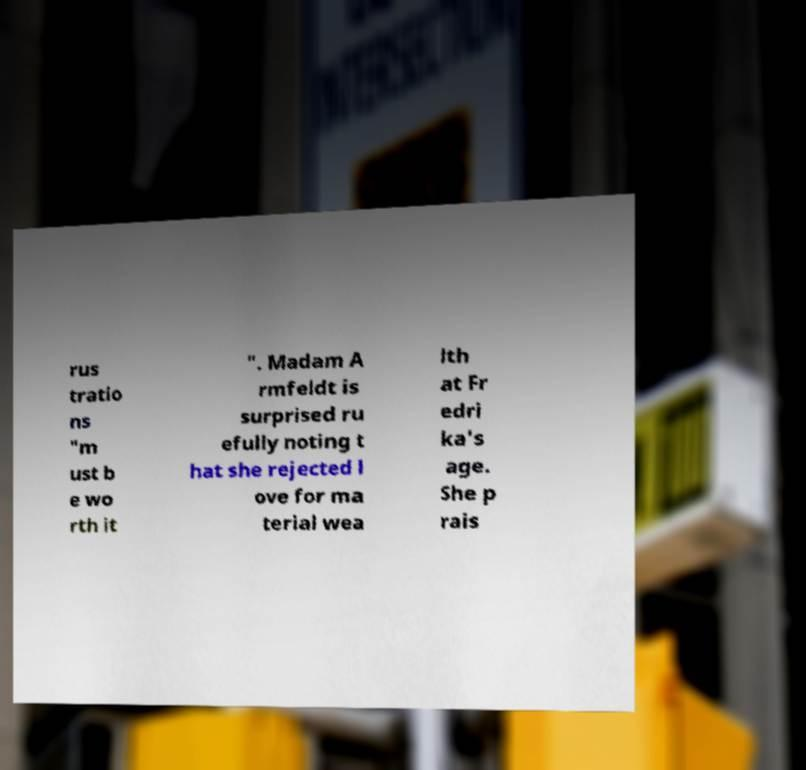Can you read and provide the text displayed in the image?This photo seems to have some interesting text. Can you extract and type it out for me? rus tratio ns "m ust b e wo rth it ". Madam A rmfeldt is surprised ru efully noting t hat she rejected l ove for ma terial wea lth at Fr edri ka's age. She p rais 